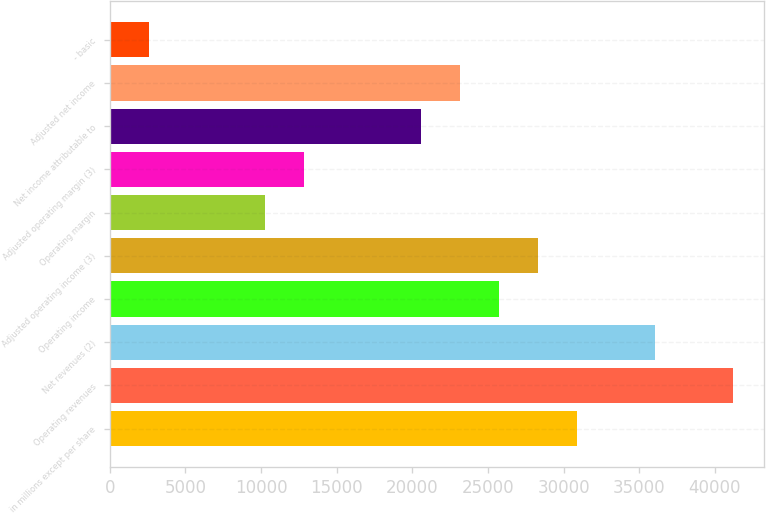Convert chart. <chart><loc_0><loc_0><loc_500><loc_500><bar_chart><fcel>in millions except per share<fcel>Operating revenues<fcel>Net revenues (2)<fcel>Operating income<fcel>Adjusted operating income (3)<fcel>Operating margin<fcel>Adjusted operating margin (3)<fcel>Net income attributable to<fcel>Adjusted net income<fcel>- basic<nl><fcel>30881<fcel>41174.2<fcel>36027.6<fcel>25734.3<fcel>28307.6<fcel>10294.4<fcel>12867.7<fcel>20587.7<fcel>23161<fcel>2574.43<nl></chart> 